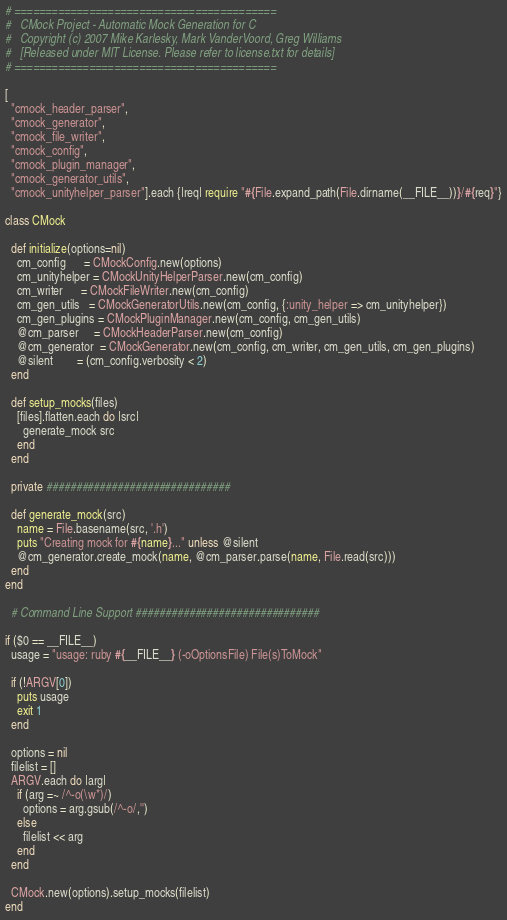Convert code to text. <code><loc_0><loc_0><loc_500><loc_500><_Ruby_># ==========================================
#   CMock Project - Automatic Mock Generation for C
#   Copyright (c) 2007 Mike Karlesky, Mark VanderVoord, Greg Williams
#   [Released under MIT License. Please refer to license.txt for details]
# ========================================== 

[ 
  "cmock_header_parser",
  "cmock_generator",
  "cmock_file_writer",
  "cmock_config",
  "cmock_plugin_manager",
  "cmock_generator_utils",
  "cmock_unityhelper_parser"].each {|req| require "#{File.expand_path(File.dirname(__FILE__))}/#{req}"}

class CMock
  
  def initialize(options=nil)
    cm_config      = CMockConfig.new(options)    
    cm_unityhelper = CMockUnityHelperParser.new(cm_config)
    cm_writer      = CMockFileWriter.new(cm_config)
    cm_gen_utils   = CMockGeneratorUtils.new(cm_config, {:unity_helper => cm_unityhelper})
    cm_gen_plugins = CMockPluginManager.new(cm_config, cm_gen_utils)
    @cm_parser     = CMockHeaderParser.new(cm_config)
    @cm_generator  = CMockGenerator.new(cm_config, cm_writer, cm_gen_utils, cm_gen_plugins)
    @silent        = (cm_config.verbosity < 2)
  end
  
  def setup_mocks(files)
    [files].flatten.each do |src|
      generate_mock src
    end
  end

  private ###############################

  def generate_mock(src)
    name = File.basename(src, '.h')
    puts "Creating mock for #{name}..." unless @silent
    @cm_generator.create_mock(name, @cm_parser.parse(name, File.read(src)))
  end
end

  # Command Line Support ###############################
  
if ($0 == __FILE__)
  usage = "usage: ruby #{__FILE__} (-oOptionsFile) File(s)ToMock"
  
  if (!ARGV[0])
    puts usage
    exit 1
  end
  
  options = nil
  filelist = []
  ARGV.each do |arg|
    if (arg =~ /^-o(\w*)/)
      options = arg.gsub(/^-o/,'')
    else
      filelist << arg
    end
  end
  
  CMock.new(options).setup_mocks(filelist)
end</code> 